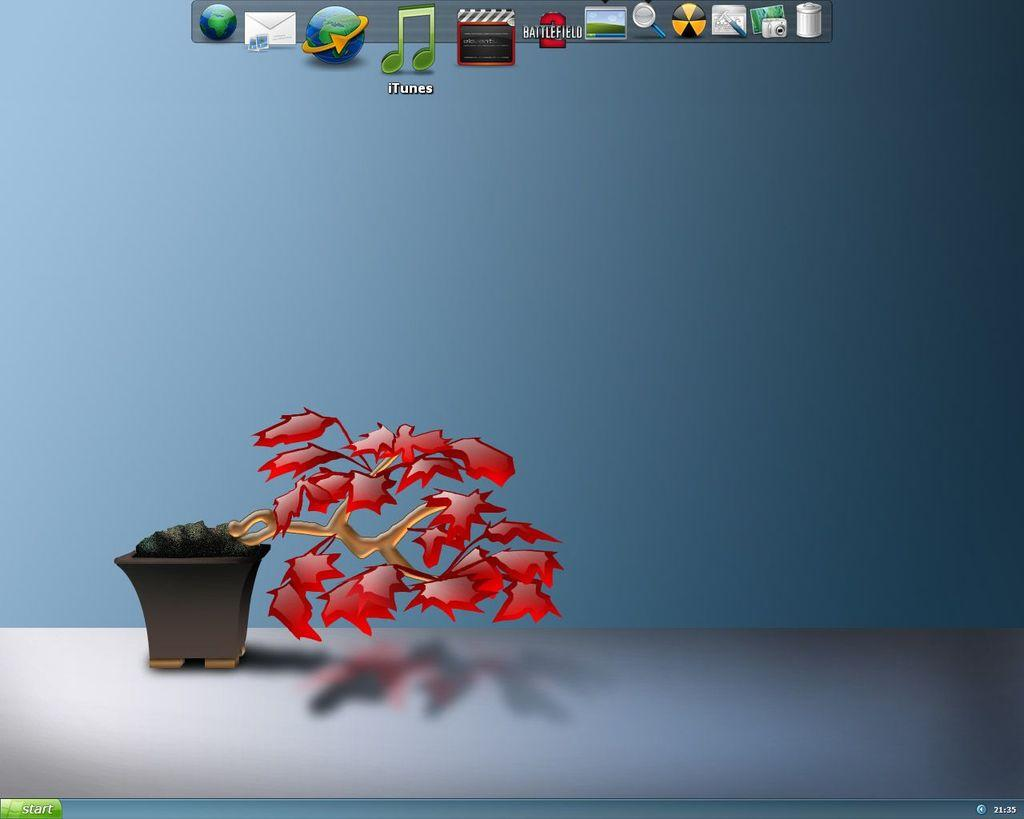What is the main object in the image? There is a screen in the image. What can be seen on the screen? The screen displays a picture of a plant and app icons. What color are the eyes of the authority figure in the image? There is no authority figure or eyes present in the image; it only features a screen with a picture of a plant and app icons. 